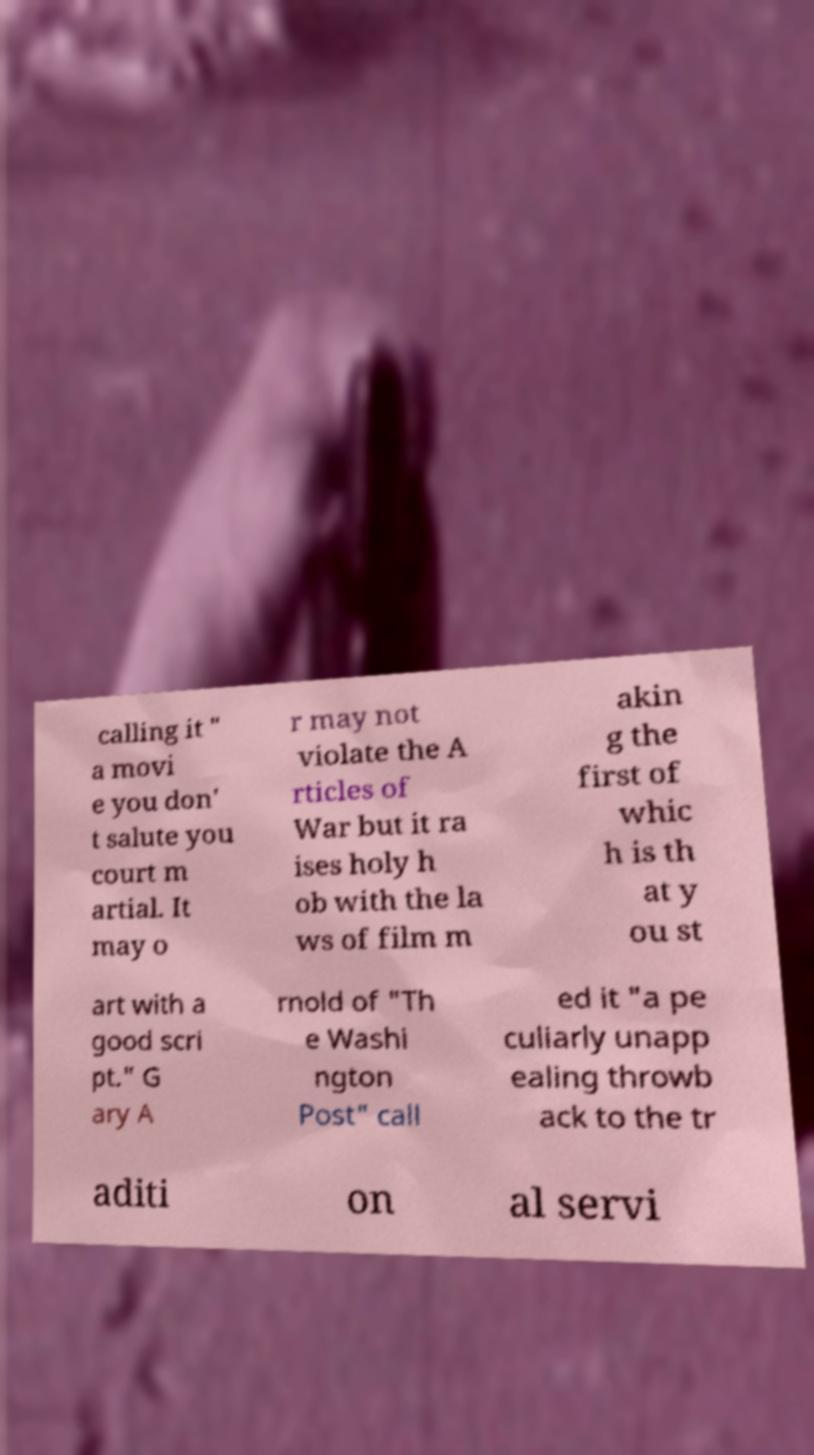What messages or text are displayed in this image? I need them in a readable, typed format. calling it " a movi e you don' t salute you court m artial. It may o r may not violate the A rticles of War but it ra ises holy h ob with the la ws of film m akin g the first of whic h is th at y ou st art with a good scri pt." G ary A rnold of "Th e Washi ngton Post" call ed it "a pe culiarly unapp ealing throwb ack to the tr aditi on al servi 